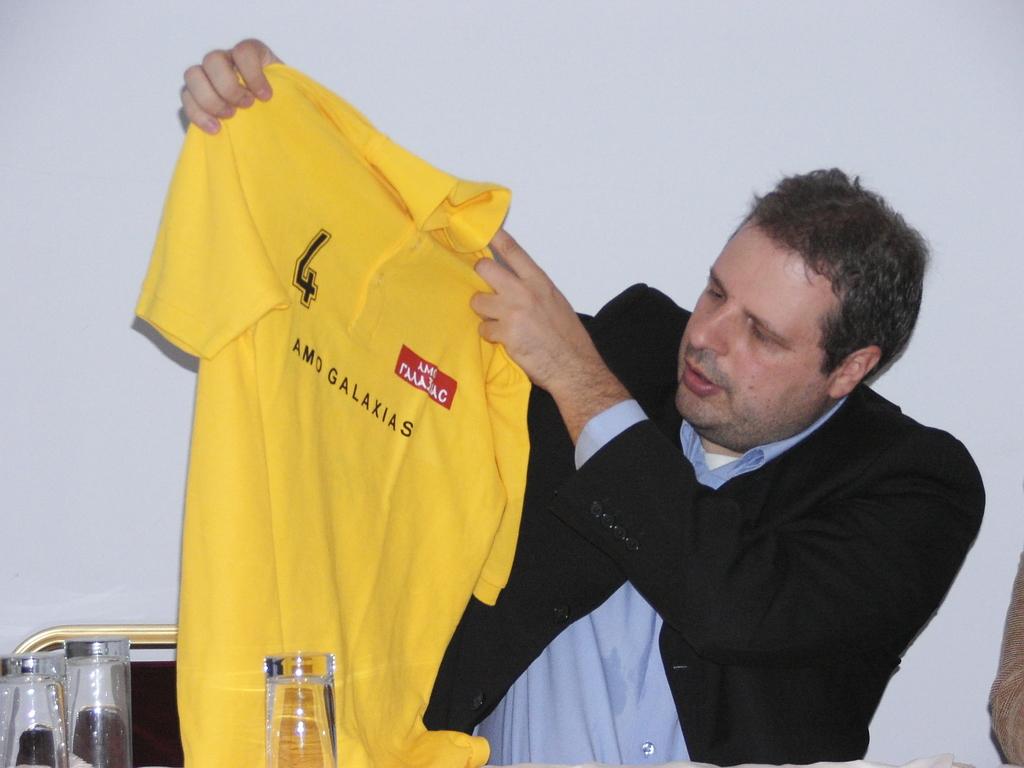What is the number displayed on the tshirt?
Your response must be concise. 4. 